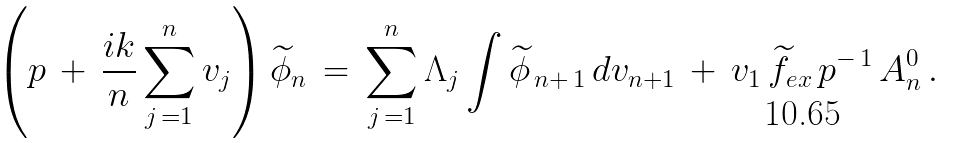Convert formula to latex. <formula><loc_0><loc_0><loc_500><loc_500>\left ( p \, + \, \frac { i k } { n } \sum _ { j \, = 1 } ^ { n } v _ { j } \right ) \widetilde { \phi } _ { n } \, = \, \sum _ { j \, = 1 } ^ { n } \Lambda _ { j } \int \widetilde { \phi } _ { \, n + \, 1 } \, d v _ { n + 1 } \, + \, v _ { 1 } \, \widetilde { f } _ { e x } \, p ^ { - \, 1 } \, A _ { n } ^ { 0 } \, .</formula> 